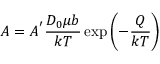Convert formula to latex. <formula><loc_0><loc_0><loc_500><loc_500>A = A ^ { ^ { \prime } } { \frac { D _ { 0 } \mu b } { k T } } \exp \left ( - { \frac { Q } { k T } } \right )</formula> 